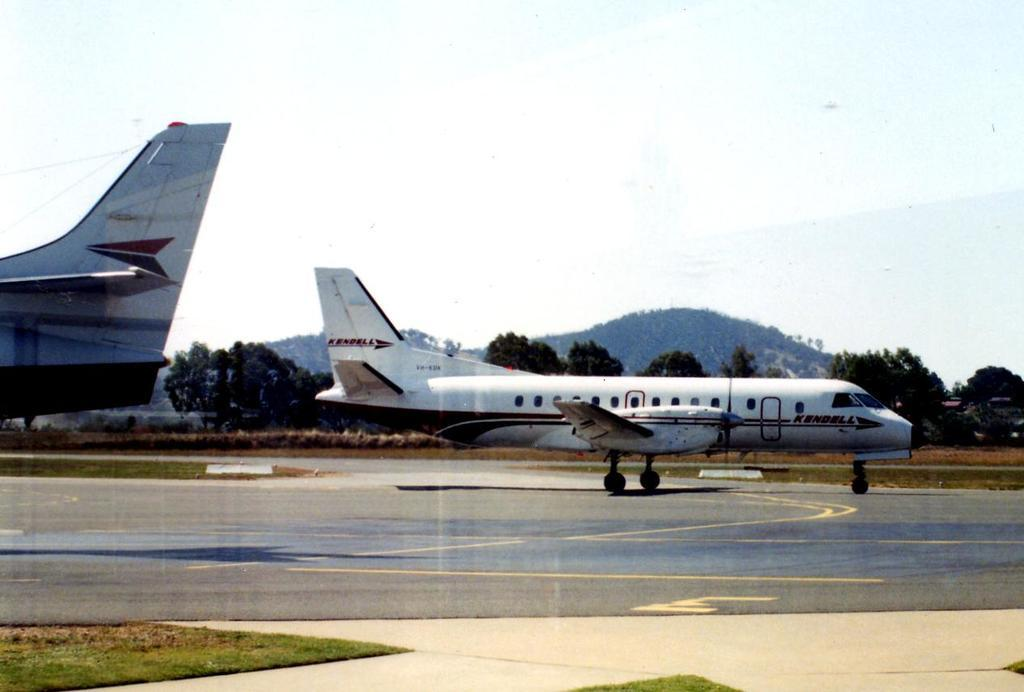<image>
Relay a brief, clear account of the picture shown. With mountains in the background, a white Kendall Plane is prepared to take off. 